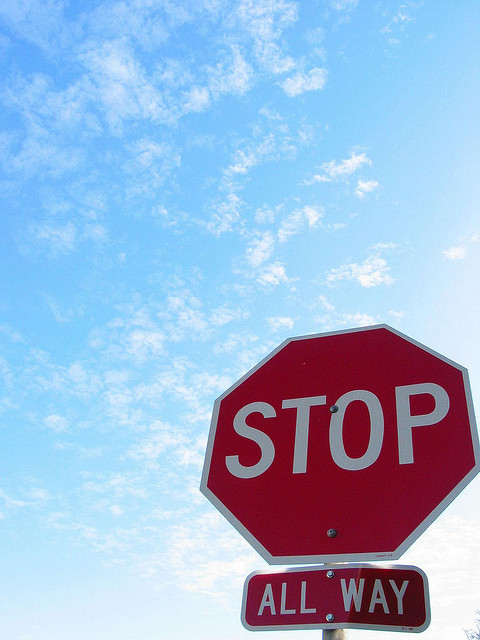Read all the text in this image. STOP AL WAY 